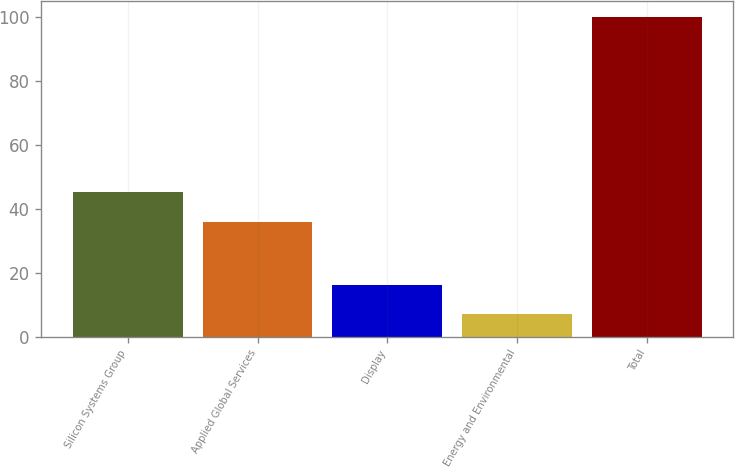Convert chart to OTSL. <chart><loc_0><loc_0><loc_500><loc_500><bar_chart><fcel>Silicon Systems Group<fcel>Applied Global Services<fcel>Display<fcel>Energy and Environmental<fcel>Total<nl><fcel>45.3<fcel>36<fcel>16.3<fcel>7<fcel>100<nl></chart> 